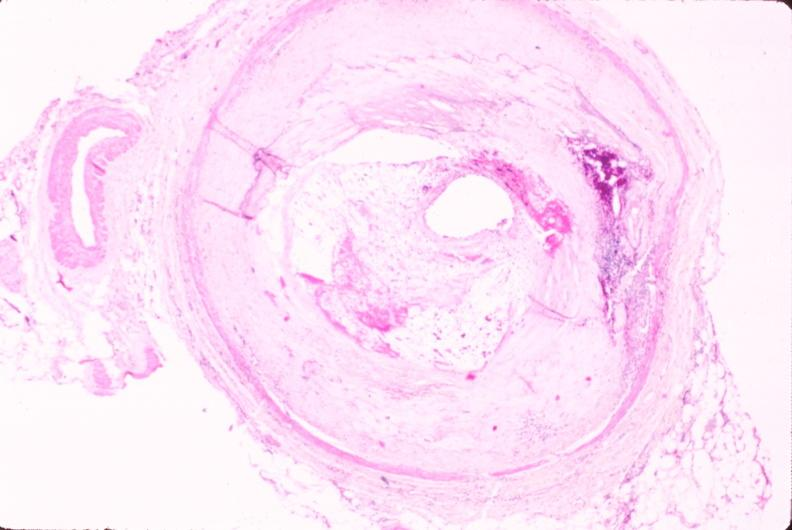what is atherosclerosis left?
Answer the question using a single word or phrase. Anterior descending coronary artery 